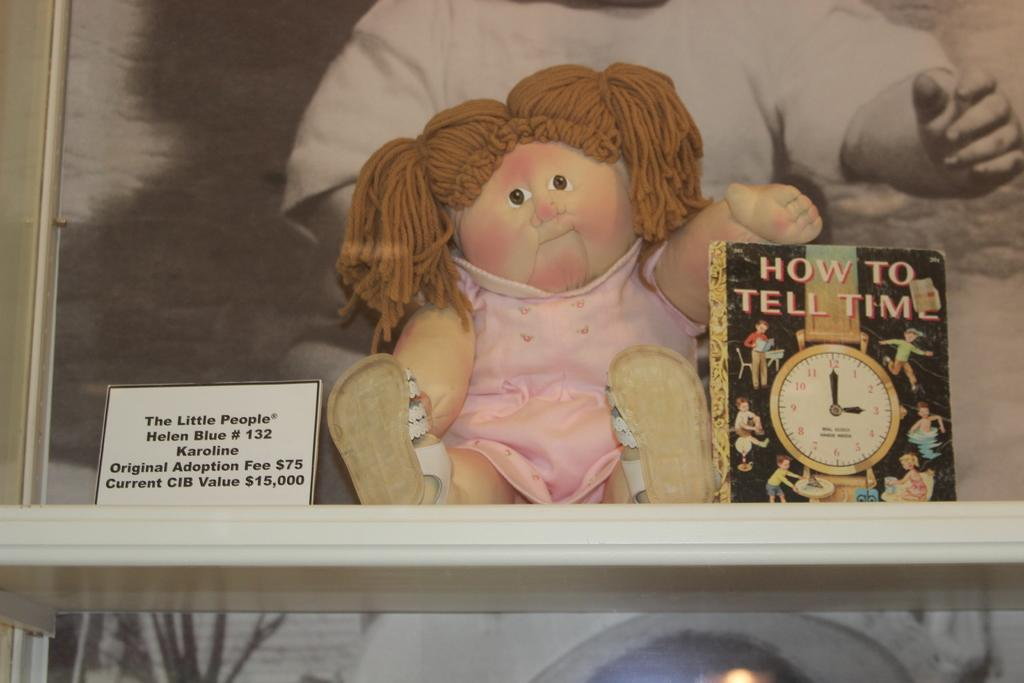<image>
Offer a succinct explanation of the picture presented. A Cabbage Patch Kid doll sits next to a book called "How to Tell Time." 